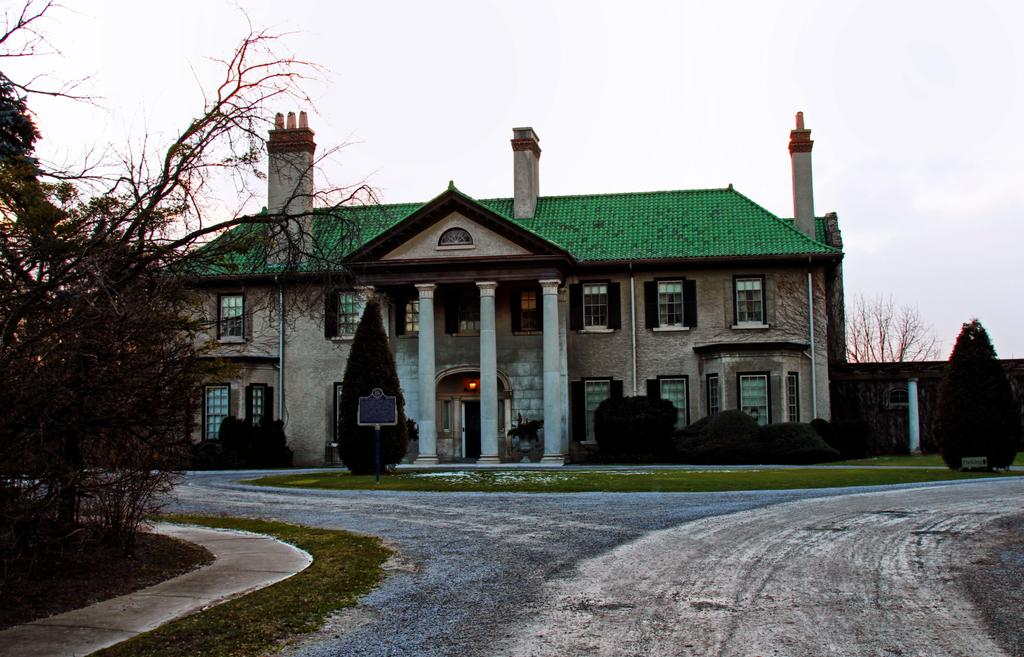What type of structure is visible in the image? There is a building in the image. What features can be observed on the building? The building has windows and pillars. What additional elements are present in the image? There is a signboard, plants, grass, a pathway, trees, and the sky is visible. What is the condition of the sky in the image? The sky looks cloudy in the image. How many fingers can be seen pointing at the building in the image? There are no fingers visible in the image, so it is not possible to determine how many fingers might be pointing at the building. 